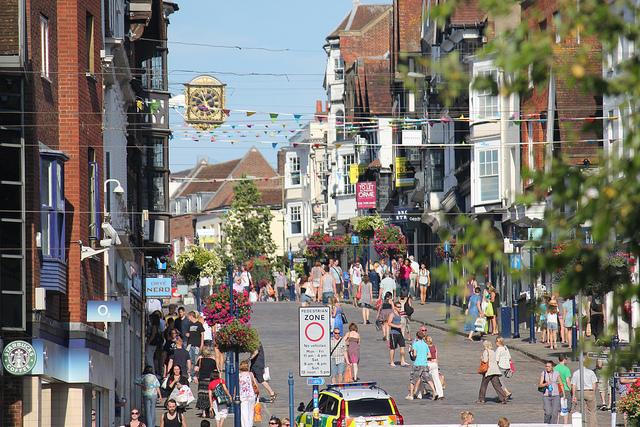Is it summer?
Keep it brief. Yes. How many people are walking down the street?
Write a very short answer. 100. Is the picture in color or black and white?
Write a very short answer. Color. What are the people holding?
Short answer required. Bags. Are there any cars on the street?
Concise answer only. Yes. 